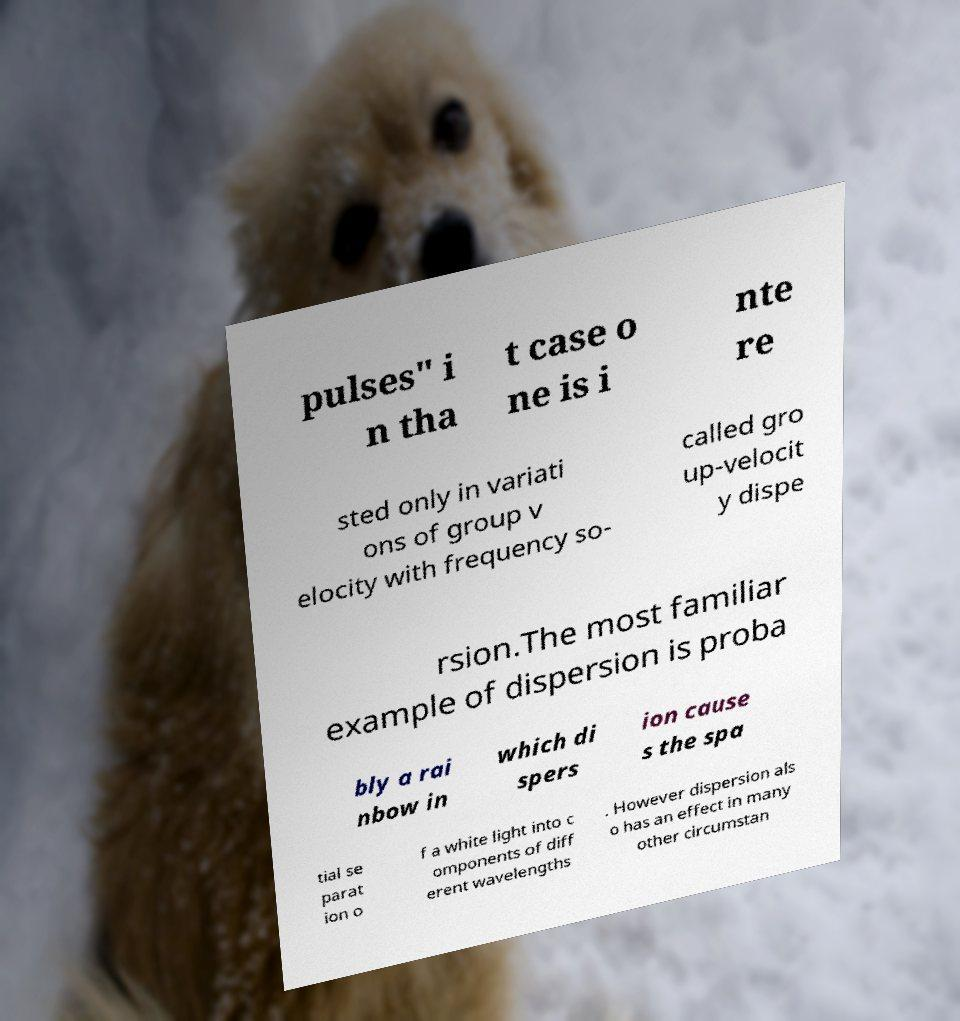Could you extract and type out the text from this image? pulses" i n tha t case o ne is i nte re sted only in variati ons of group v elocity with frequency so- called gro up-velocit y dispe rsion.The most familiar example of dispersion is proba bly a rai nbow in which di spers ion cause s the spa tial se parat ion o f a white light into c omponents of diff erent wavelengths . However dispersion als o has an effect in many other circumstan 